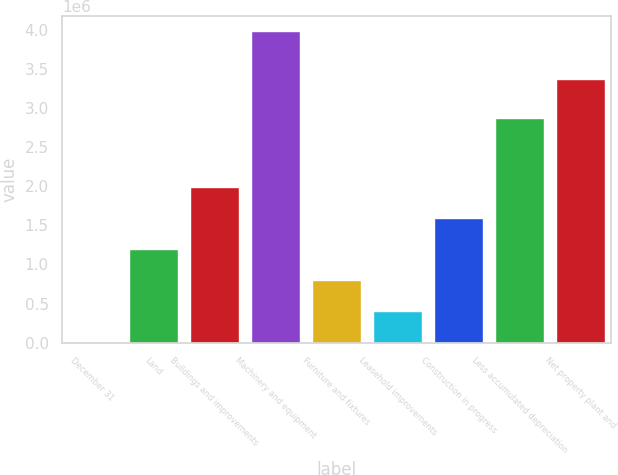Convert chart. <chart><loc_0><loc_0><loc_500><loc_500><bar_chart><fcel>December 31<fcel>Land<fcel>Buildings and improvements<fcel>Machinery and equipment<fcel>Furniture and fixtures<fcel>Leasehold improvements<fcel>Construction in progress<fcel>Less accumulated depreciation<fcel>Net property plant and<nl><fcel>2016<fcel>1.19522e+06<fcel>1.99068e+06<fcel>3.97935e+06<fcel>797483<fcel>399749<fcel>1.59295e+06<fcel>2.87343e+06<fcel>3.37035e+06<nl></chart> 